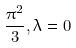Convert formula to latex. <formula><loc_0><loc_0><loc_500><loc_500>\frac { \pi ^ { 2 } } { 3 } , \lambda = 0</formula> 